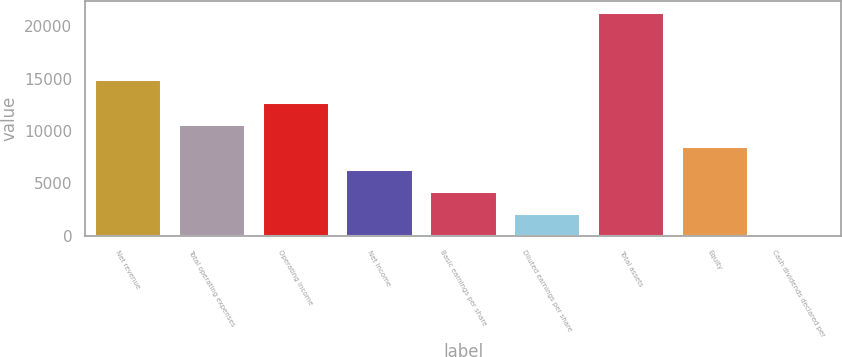<chart> <loc_0><loc_0><loc_500><loc_500><bar_chart><fcel>Net revenue<fcel>Total operating expenses<fcel>Operating income<fcel>Net income<fcel>Basic earnings per share<fcel>Diluted earnings per share<fcel>Total assets<fcel>Equity<fcel>Cash dividends declared per<nl><fcel>14930.6<fcel>10665<fcel>12797.8<fcel>6399.34<fcel>4266.53<fcel>2133.72<fcel>21329<fcel>8532.15<fcel>0.91<nl></chart> 